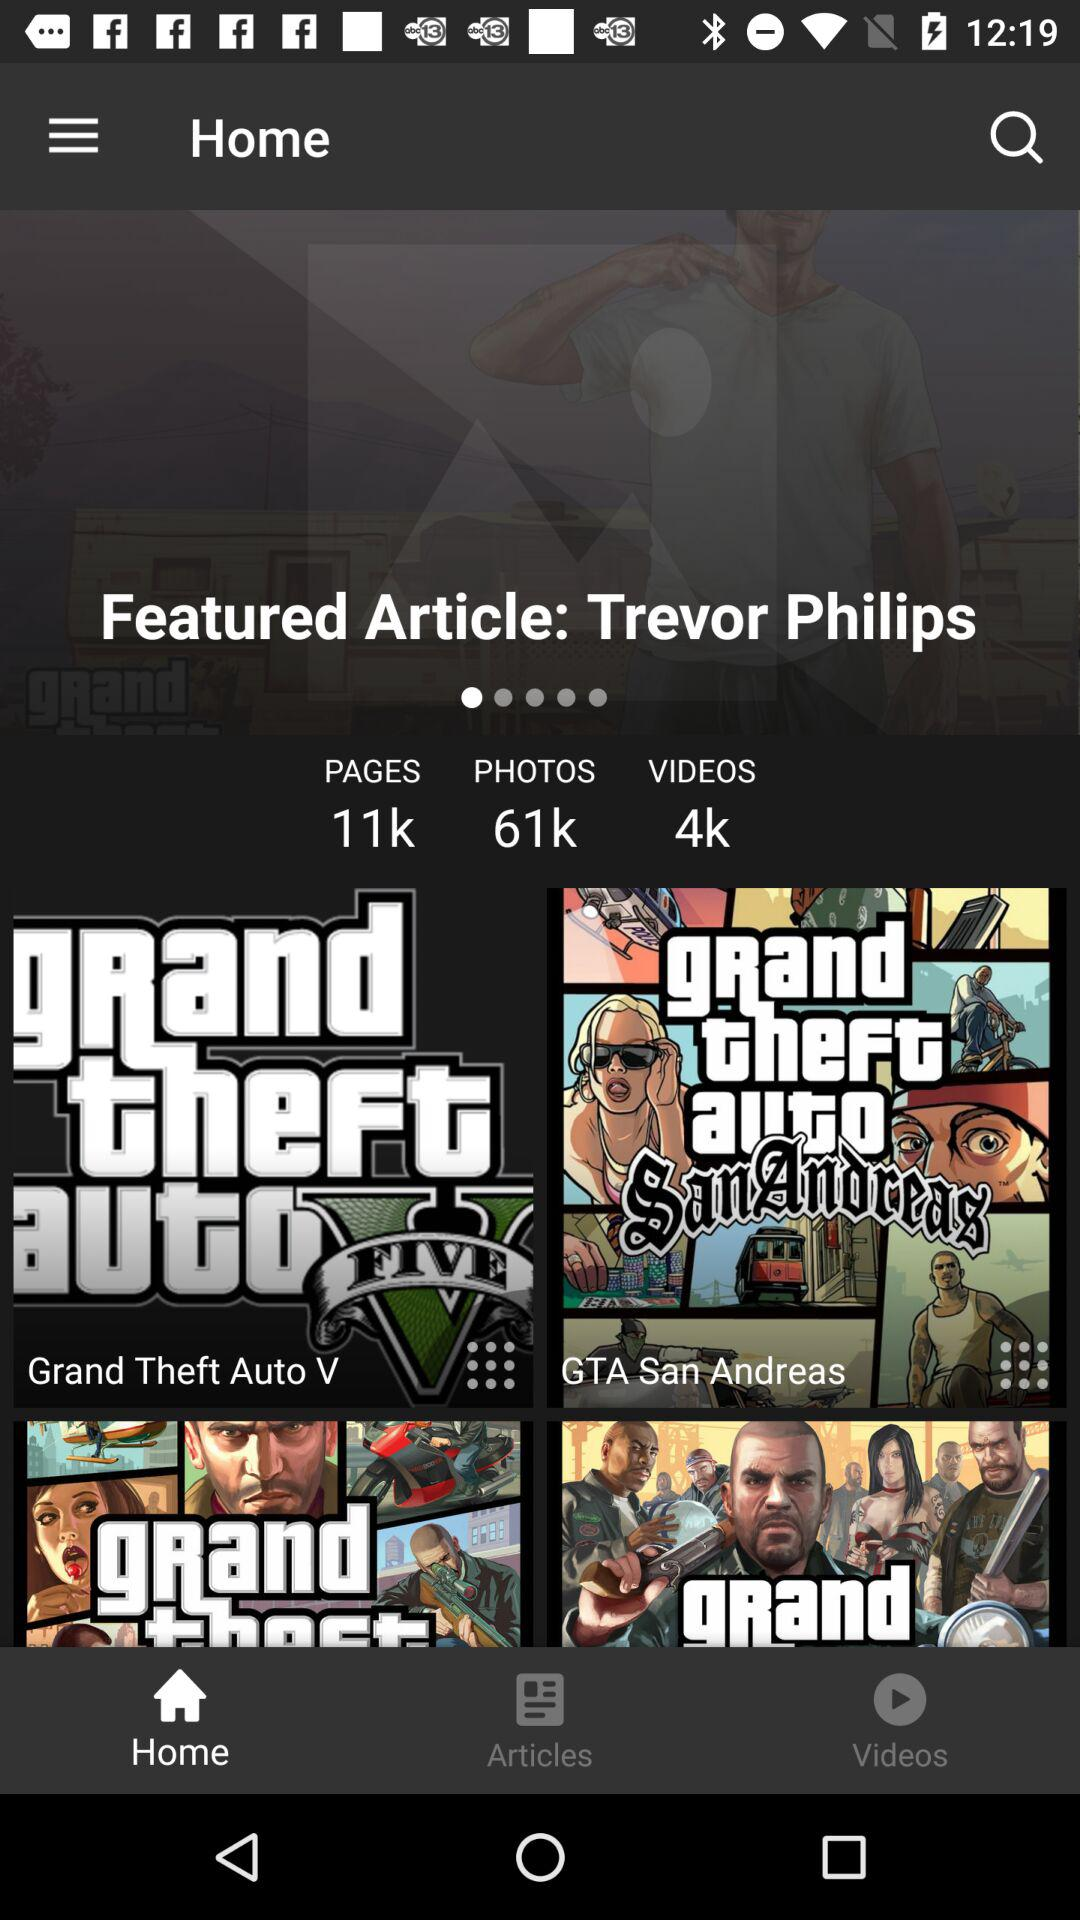Which tab has been selected? The selected tab is "Home". 